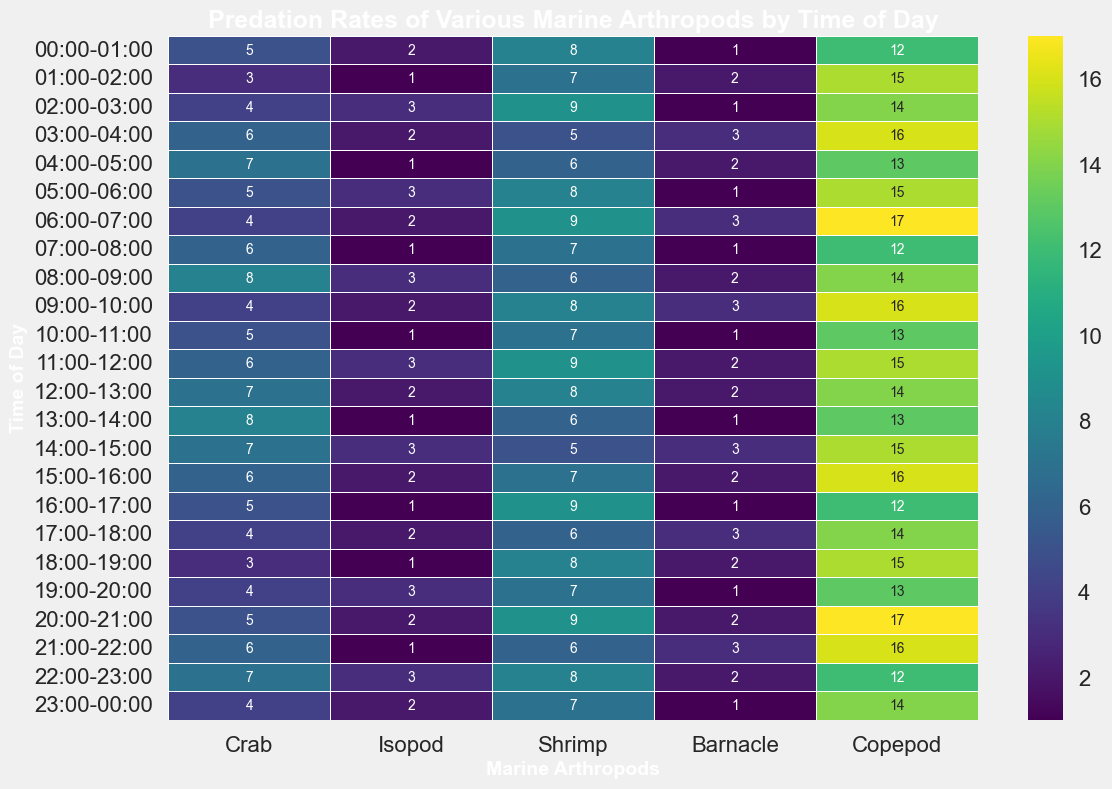What time of day has the highest predation rate for Crabs? Scan through the "Crab" column and find the highest value, which is 8. This occurs at 08:00-09:00 and 13:00-14:00.
Answer: 08:00-09:00, 13:00-14:00 Which marine arthropod has the highest predation rate at 06:00-07:00? Look at the row corresponding to 06:00-07:00, and identify the highest value. The highest value is 17, which is for Copepod.
Answer: Copepod What time of day shows the lowest predation rate for Shrimp? Scan the "Shrimp" column to find the lowest value, which is 5. This occurs at 03:00-04:00 and 14:00-15:00.
Answer: 03:00-04:00, 14:00-15:00 Compare the predation rate of Isopods and Barnacles at 21:00-22:00. Which one is higher? At 21:00-22:00, the predation rate for Isopods is 1 and for Barnacles is 3. Since 3 is greater than 1, Barnacle has a higher predation rate.
Answer: Barnacle What is the average predation rate of Copepods during 00:00-06:00? Sum the predation rates of Copepods from 00:00-01:00 to 05:00-06:00, which are 12, 15, 14, 16, 13, and 15, giving a total of 85. Divide by 6 (number of time intervals), resulting in an average of 14.17.
Answer: 14.17 During which time interval is the predation rate for Barnacles consistently high, i.e., greater than 2? Identify the rows where the predation rate of Barnacles is greater than 2. This is true for 03:00-04:00, 06:00-07:00, 09:00-10:00, 14:00-15:00, 15:00-16:00, 17:00-18:00, and 21:00-22:00.
Answer: (03:00-04:00, 06:00-07:00, 09:00-10:00, 14:00-15:00, 15:00-16:00, 17:00-18:00, 21:00-22:00) What is the total predation rate for all marine arthropods at 12:00-13:00? Add the predation rates for all marine arthropods for the 12:00-13:00 interval: Crab (7), Isopod (2), Shrimp (8), Barnacle (2), and Copepod (14). The total is 7 + 2 + 8 + 2 + 14 = 33.
Answer: 33 Which marine arthropod shows the greatest variance in predation rates across the 24-hour period? Determine the variance for each column. Copepod has the predation rates: 12, 15, 14, 16, 13, 15, 17, 12, 14, 16, 13, 15, 14, 13, 15, 16, 12, 14, 15, 13, 17, 16, 12, 14 which seem to fluctuate the most. Calculating and comparing variances or ranges confirms that Copepods have a higher variability.
Answer: Copepod What is the average number of predation events for Crabs and how does it compare to Isopods? Sum the predation rates for Crabs: 5, 3, 4, 6, 7, 5, 4, 6, 8, 4, 5, 6, 7, 8, 7, 6, 5, 4, 3, 4, 5, 6, 7, 4 resulting in 120. Divide by 24 to get an average of 5. For Isopods: 2, 1, 3, 2, 1, 3, 2, 1, 3, 2, 1, 3, 2, 1, 3, 2, 1, 2, 1, 3, 2, 1, 3, 2 resulting in 45. Divide by 24 to get an average of 1.875. Crab’s average predation rate is significantly higher.
Answer: 5 (Crab), 1.875 (Isopod) What time of day does the predation rate for Barnacles peak? Look through the "Barnacle" column to find the highest value, which is 3. This value is repeated at several times: 03:00-04:00, 06:00-07:00, 09:00-10:00, 14:00-15:00, 15:00-16:00, 17:00-18:00, and 21:00-22:00.
Answer: (03:00-04:00, 06:00-07:00, 09:00-10:00, 14:00-15:00, 15:00-16:00, 17:00-18:00, 21:00-22:00) 